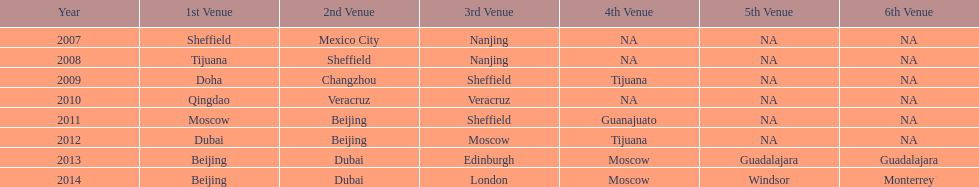In which year was there a higher count of venues, 2007 or 2012? 2012. 